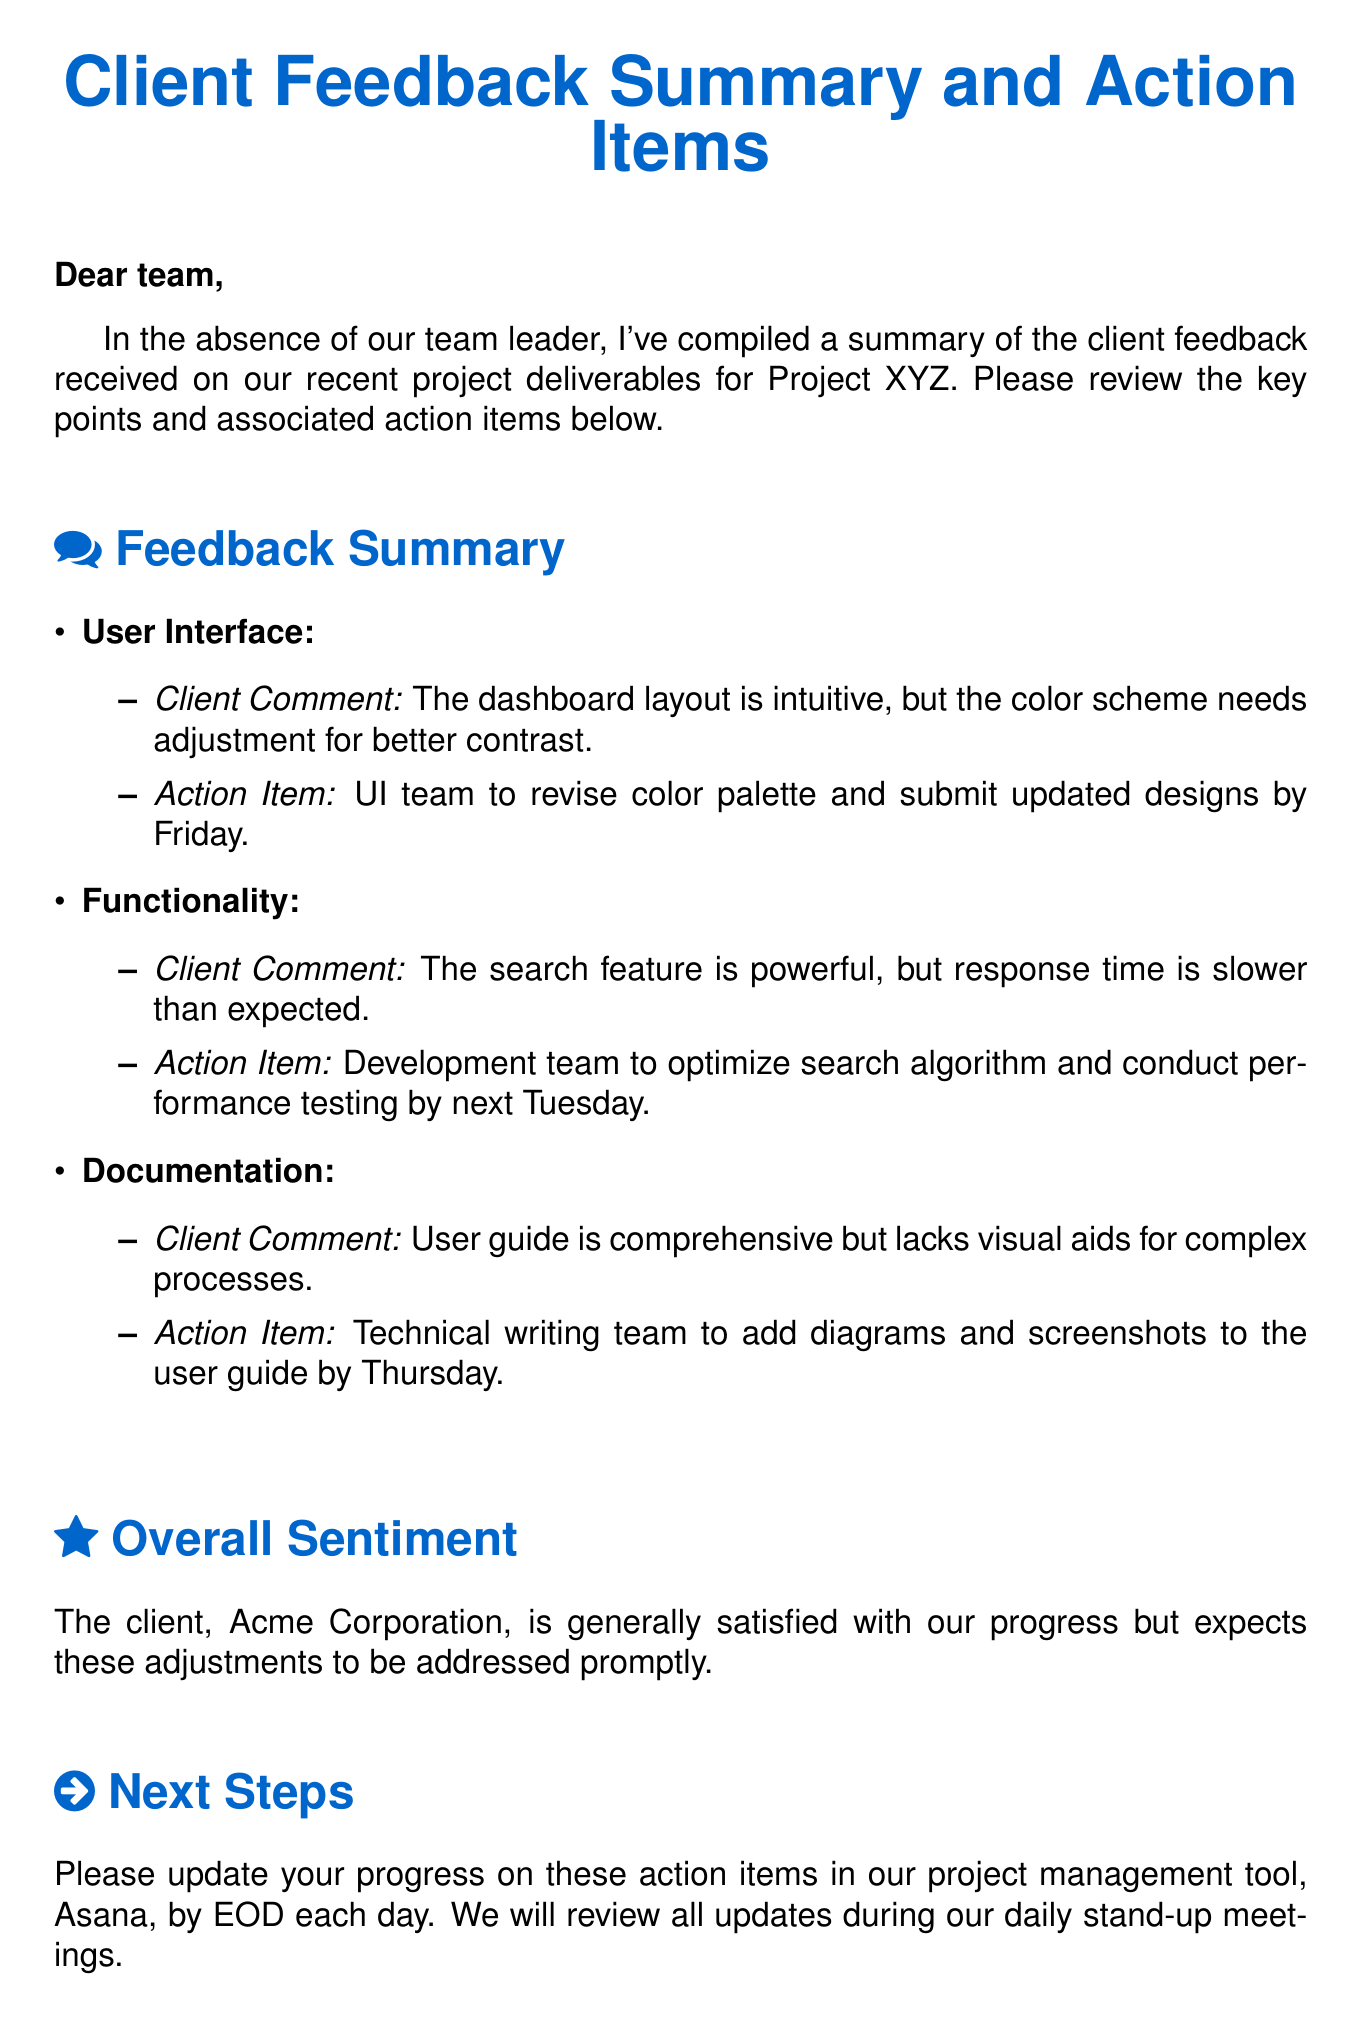What is the project name? The project name is mentioned in the introductory section of the email, which refers to "Project XYZ."
Answer: Project XYZ Who is the client? The client's name is stated in the overall sentiment section of the email as "Acme Corporation."
Answer: Acme Corporation What is the action item for the UI team? The action item for the UI team involves revising the color palette and submitting updated designs by Friday.
Answer: Revise color palette and submit updated designs by Friday What should the development team optimize? The development team needs to optimize the search algorithm as indicated in the feedback summary under functionality.
Answer: Search algorithm When is the deadline for the documentation update? The email specifies that the technical writing team should add diagrams and screenshots to the user guide by Thursday.
Answer: Thursday What is the client's overall sentiment towards the project? The overall sentiment indicates that the client is generally satisfied with the progress of the project but expects timely adjustments.
Answer: Generally satisfied What tool should updates be entered into? The email instructs the team to update their progress in "Asana," which is the project management tool mentioned.
Answer: Asana What should the team do if they have questions? The email closes by stating that team members should reach out if they have any questions or concerns.
Answer: Reach out Which team is responsible for revising the color palette? The feedback summary clearly states that the UI team is responsible for revising the color palette.
Answer: UI team 